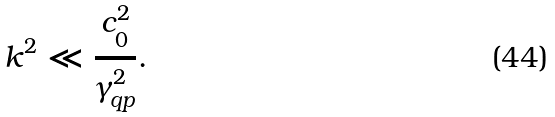Convert formula to latex. <formula><loc_0><loc_0><loc_500><loc_500>k ^ { 2 } \ll \frac { c _ { 0 } ^ { 2 } } { \gamma _ { q p } ^ { 2 } } .</formula> 